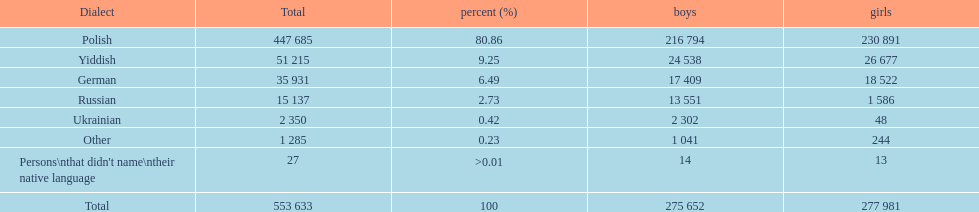How many people didn't name their native language? 27. 